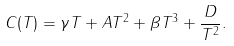<formula> <loc_0><loc_0><loc_500><loc_500>C ( T ) = \gamma T + A T ^ { 2 } + \beta T ^ { 3 } + \frac { D } { T ^ { 2 } } .</formula> 